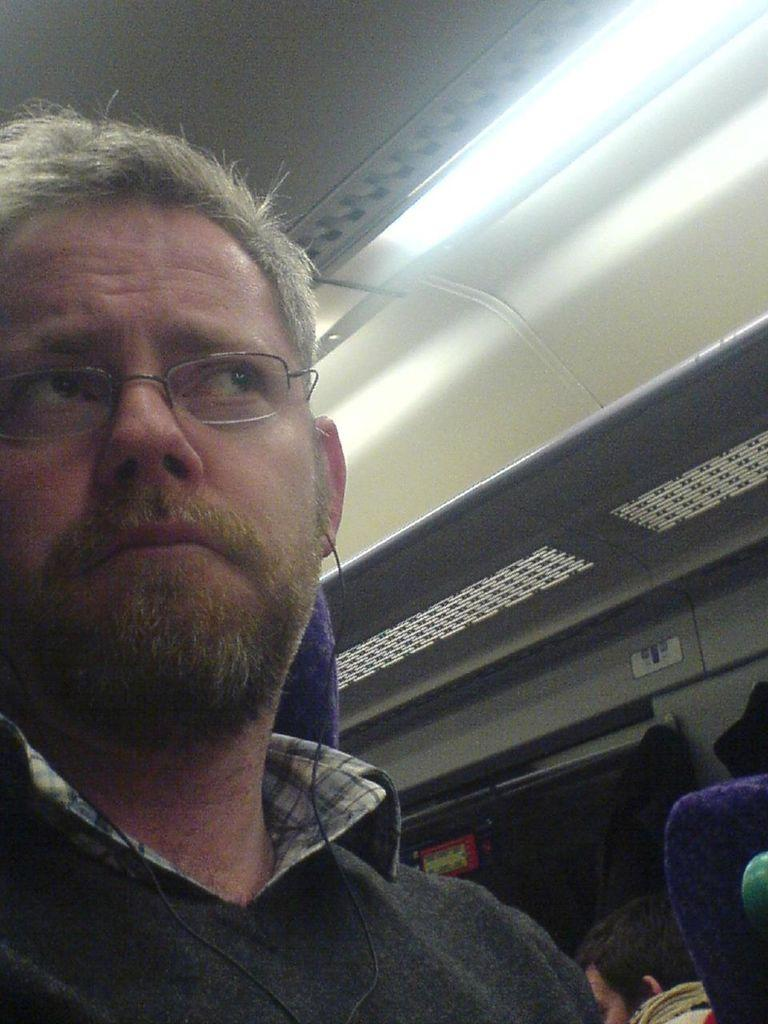What is the setting of the image? The image shows the inside view of a vehicle. How many people are in the vehicle? There are two persons sitting in the vehicle. What is provided for passengers to sit on in the vehicle? The vehicle has seats. Is there any source of light in the vehicle? Yes, there is a light in the vehicle. Can you see outside the vehicle in the image? Yes, there is a window in the vehicle. What type of tree can be seen growing through the window in the image? There is no tree visible in the image; it shows the inside view of a vehicle with a window, but no tree is present. What color are the lips of the person sitting in the driver's seat? The image does not show the lips of the person sitting in the driver's seat, so we cannot determine their color. 